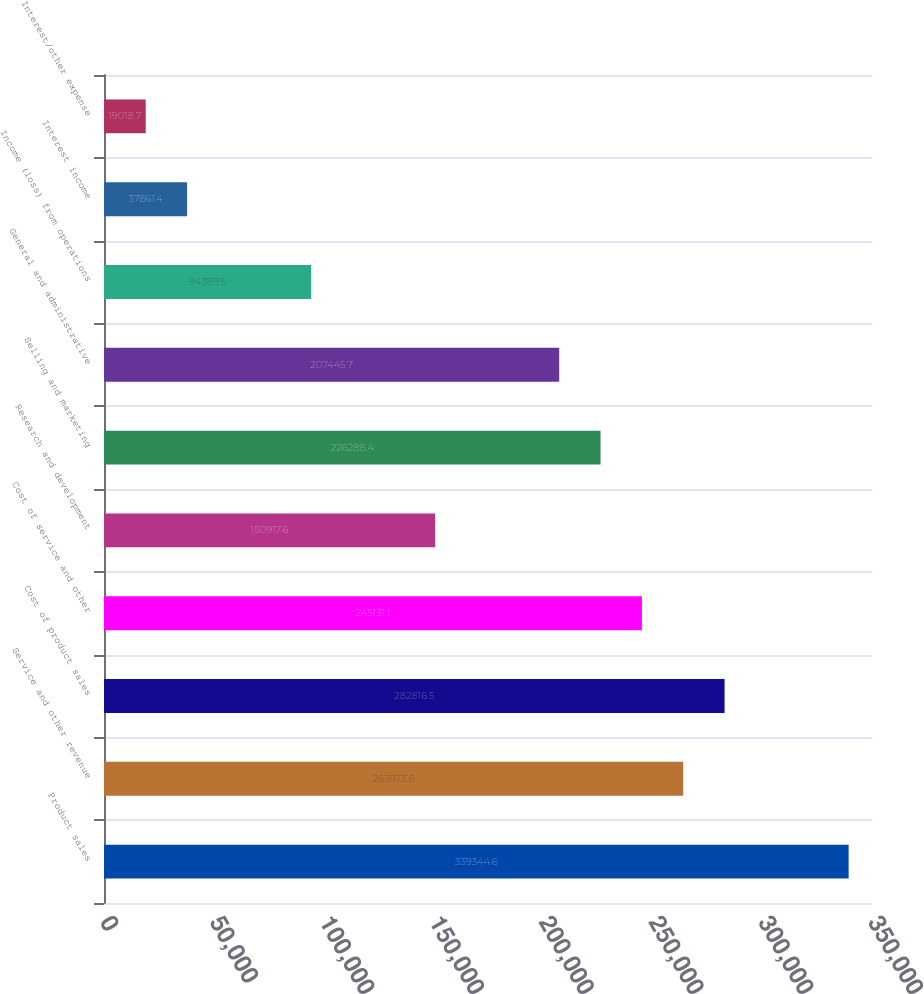<chart> <loc_0><loc_0><loc_500><loc_500><bar_chart><fcel>Product sales<fcel>Service and other revenue<fcel>Cost of product sales<fcel>Cost of service and other<fcel>Research and development<fcel>Selling and marketing<fcel>General and administrative<fcel>Income (loss) from operations<fcel>Interest income<fcel>Interest/other expense<nl><fcel>339345<fcel>263974<fcel>282816<fcel>245131<fcel>150918<fcel>226288<fcel>207446<fcel>94389.5<fcel>37861.4<fcel>19018.7<nl></chart> 